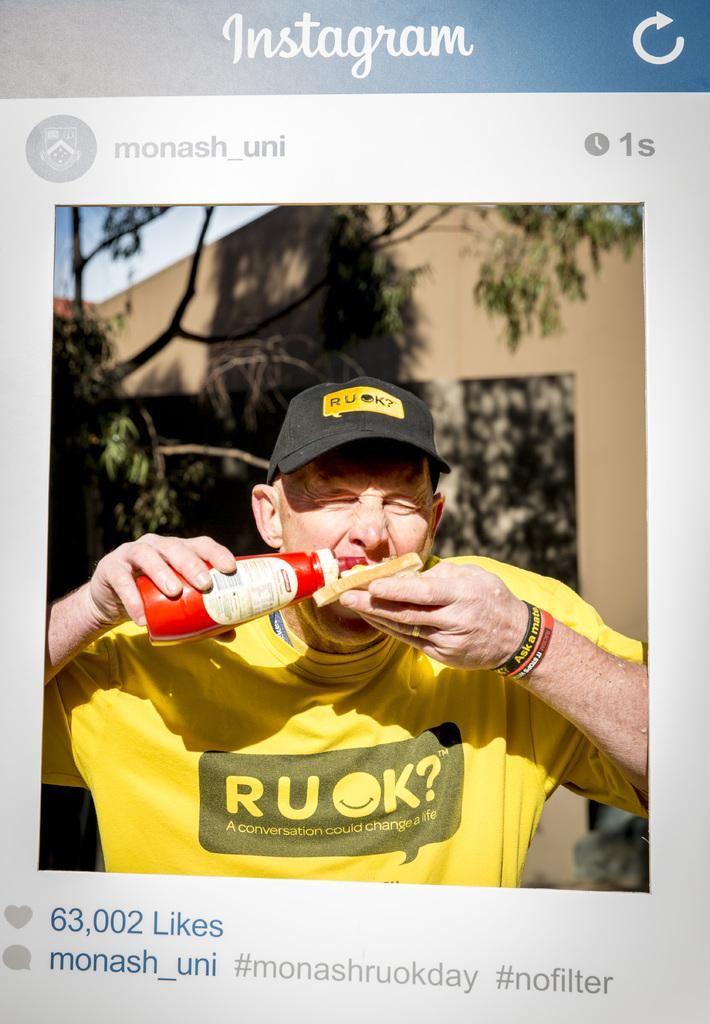<image>
Render a clear and concise summary of the photo. An Instagram picture hows a man with a bottle of ketchup. 